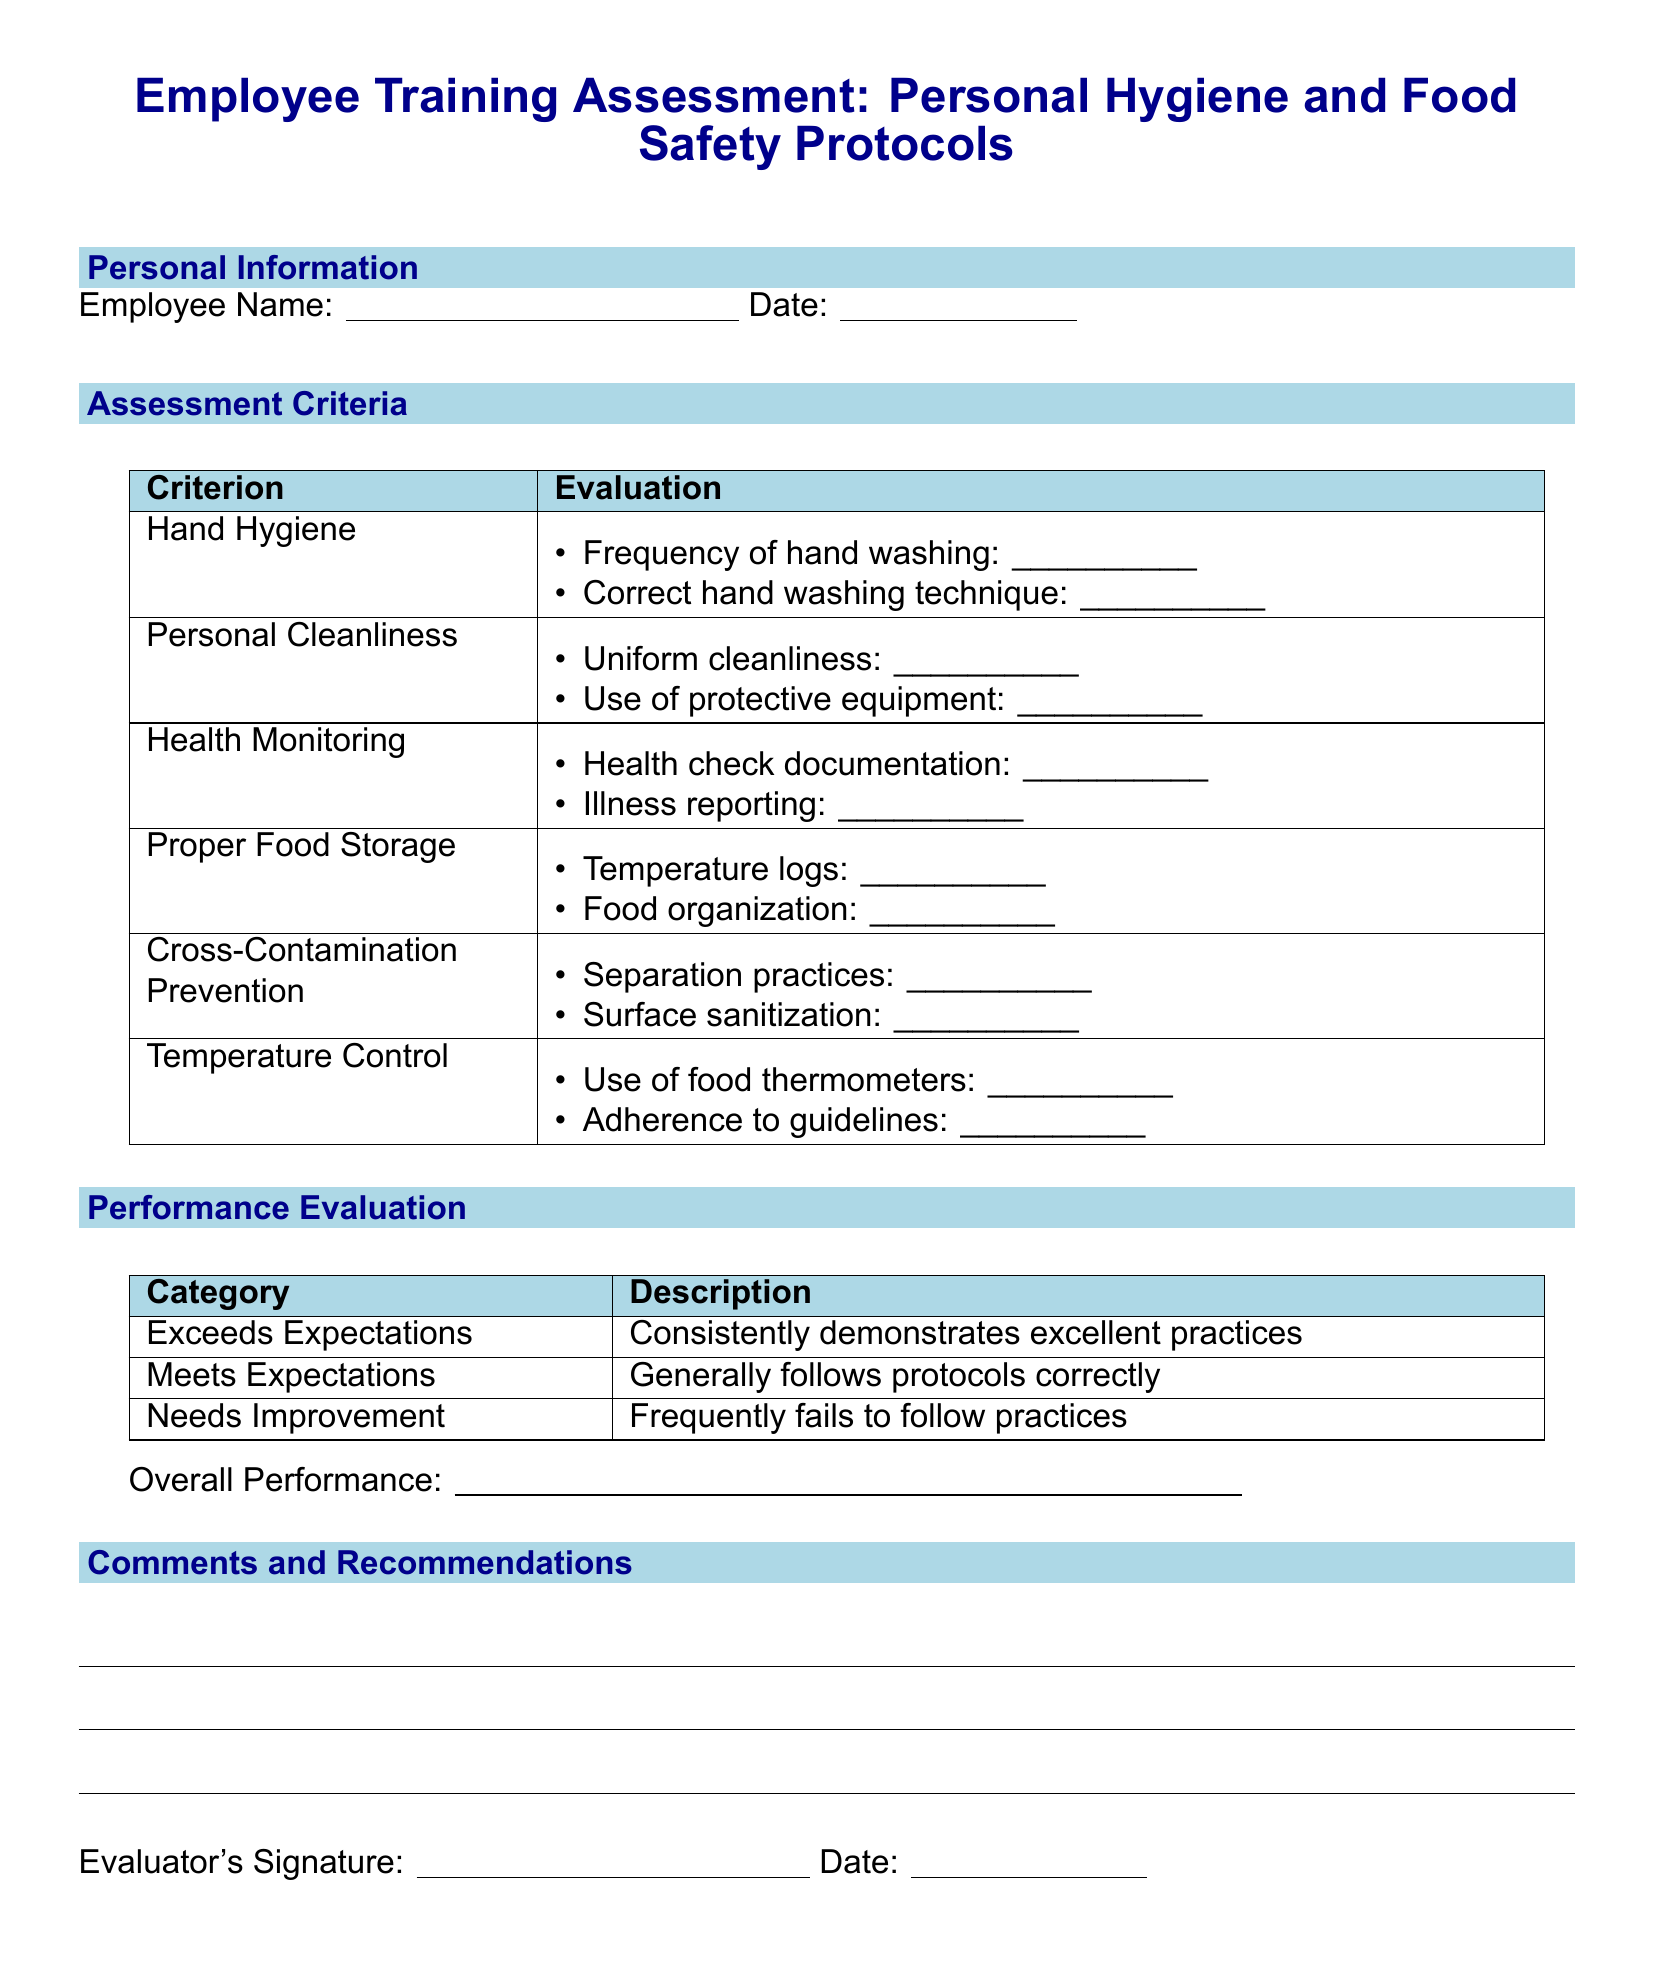What is the title of the document? The title is stated at the beginning of the document and indicates the purpose of the form.
Answer: Employee Training Assessment: Personal Hygiene and Food Safety Protocols What must be documented under Health Monitoring? The document specifies two key areas that require documentation, which are crucial for health monitoring of employees.
Answer: Health check documentation, Illness reporting What are the two criteria listed under Cross-Contamination Prevention? The document outlines specific practices aimed at preventing cross-contamination that need to be assessed.
Answer: Separation practices, Surface sanitization What is the performance evaluation category that indicates excellent practices? The document categorizes employee performance into three levels, with one level indicating excellence.
Answer: Exceeds Expectations What must be included in the comments and recommendations section? This section is designed for evaluators to provide feedback, and no specific instructions are provided for content.
Answer: Suggestions and observations from the evaluator What is the overall performance assessment phrase? This phrase is found at the end of the performance evaluation and allows for summarizing the evaluation.
Answer: Overall Performance: What is the significance of the evaluator's signature? The signature signifies the completion and validation of the assessment as a formal process.
Answer: Verifies the assessment What color is used for the header sections in the evaluation table? The color used in the header sections is meant to provide a visual distinction for better readability.
Answer: Light blue What date is required for the employee’s assessment? The document includes a section for the date, which is relevant for record-keeping and tracking training assessments over time.
Answer: Date: 